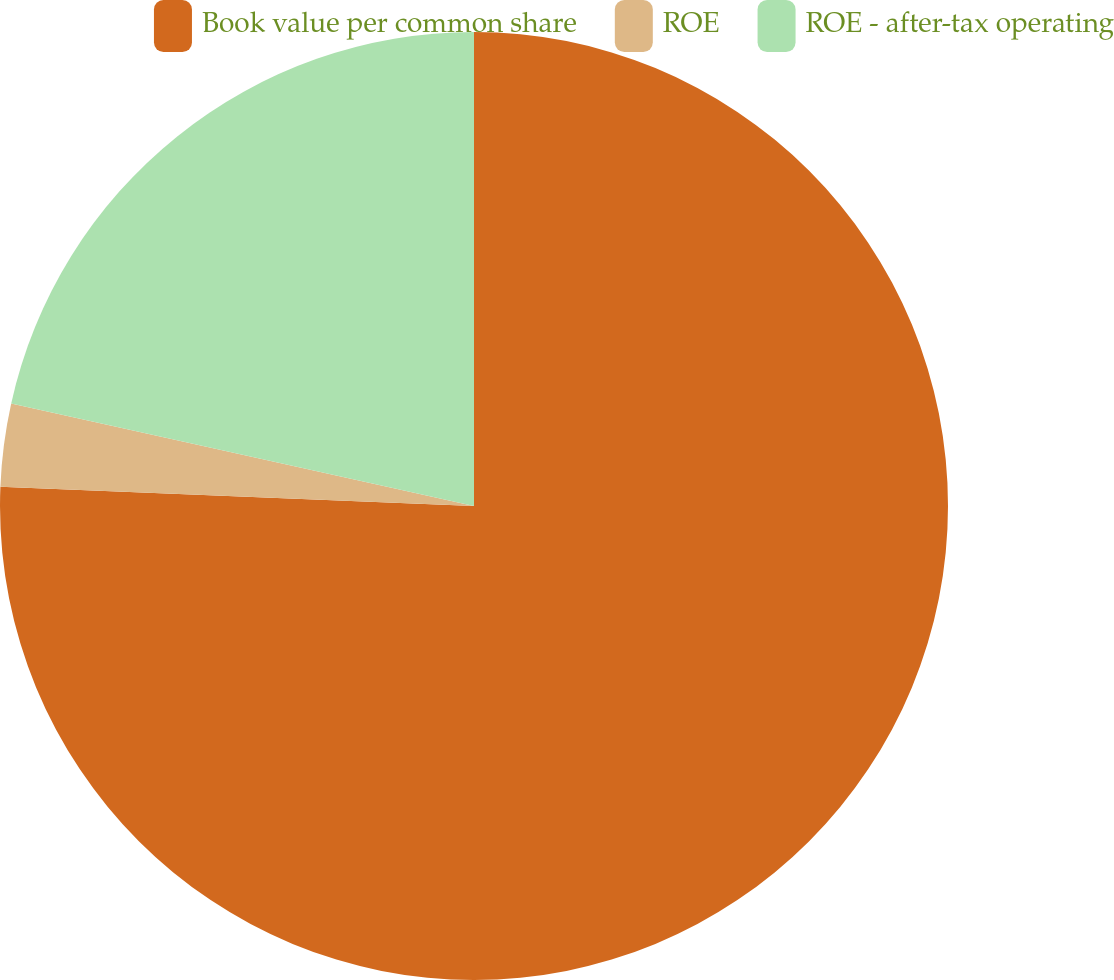Convert chart to OTSL. <chart><loc_0><loc_0><loc_500><loc_500><pie_chart><fcel>Book value per common share<fcel>ROE<fcel>ROE - after-tax operating<nl><fcel>75.64%<fcel>2.82%<fcel>21.53%<nl></chart> 